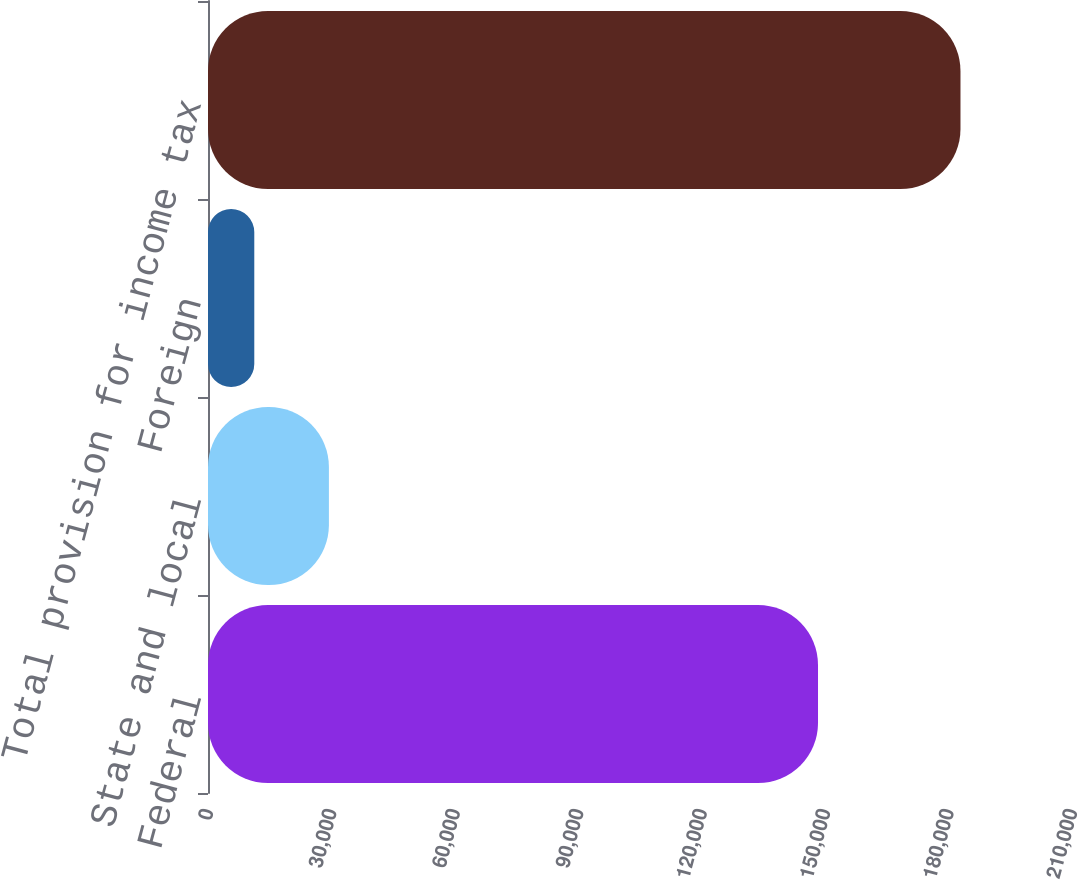<chart> <loc_0><loc_0><loc_500><loc_500><bar_chart><fcel>Federal<fcel>State and local<fcel>Foreign<fcel>Total provision for income tax<nl><fcel>148266<fcel>29387<fcel>11249<fcel>182894<nl></chart> 